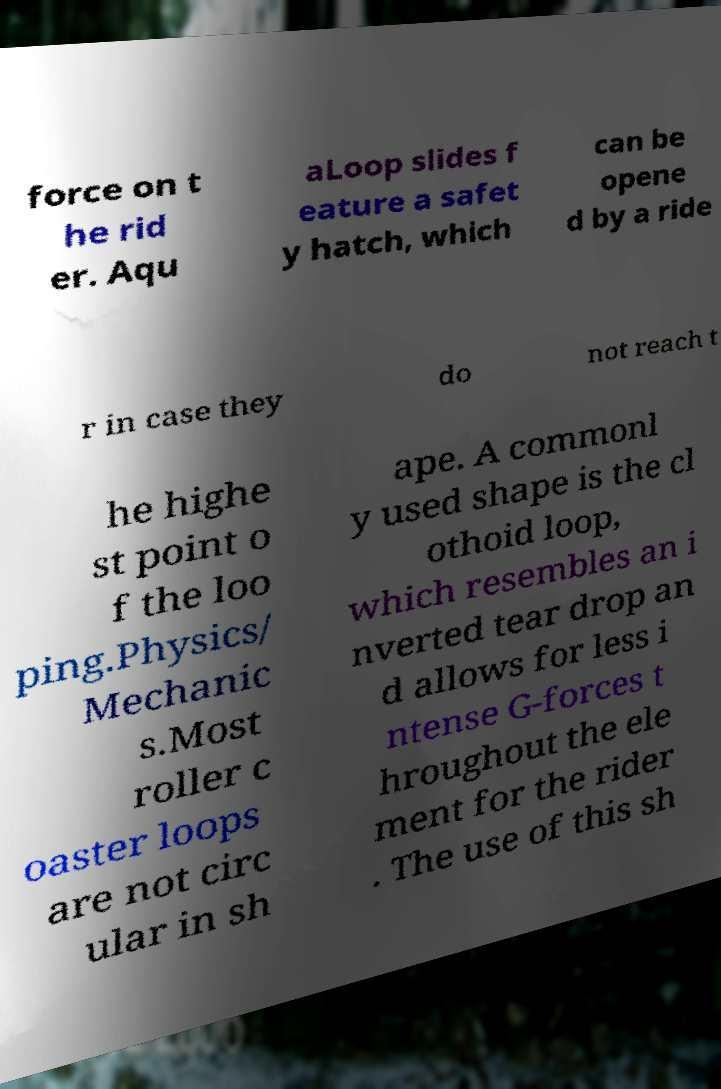Can you accurately transcribe the text from the provided image for me? force on t he rid er. Aqu aLoop slides f eature a safet y hatch, which can be opene d by a ride r in case they do not reach t he highe st point o f the loo ping.Physics/ Mechanic s.Most roller c oaster loops are not circ ular in sh ape. A commonl y used shape is the cl othoid loop, which resembles an i nverted tear drop an d allows for less i ntense G-forces t hroughout the ele ment for the rider . The use of this sh 